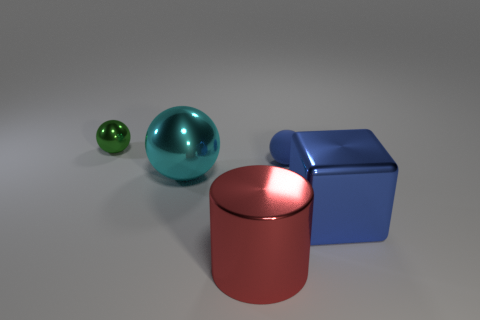Subtract all green shiny spheres. How many spheres are left? 2 Subtract all cyan blocks. How many green balls are left? 1 Add 1 tiny green shiny spheres. How many objects exist? 6 Subtract all cyan balls. How many balls are left? 2 Subtract 1 cubes. How many cubes are left? 0 Subtract 0 brown cylinders. How many objects are left? 5 Subtract all cylinders. How many objects are left? 4 Subtract all brown spheres. Subtract all brown cylinders. How many spheres are left? 3 Subtract all gray metallic cubes. Subtract all small green metallic balls. How many objects are left? 4 Add 1 tiny metal balls. How many tiny metal balls are left? 2 